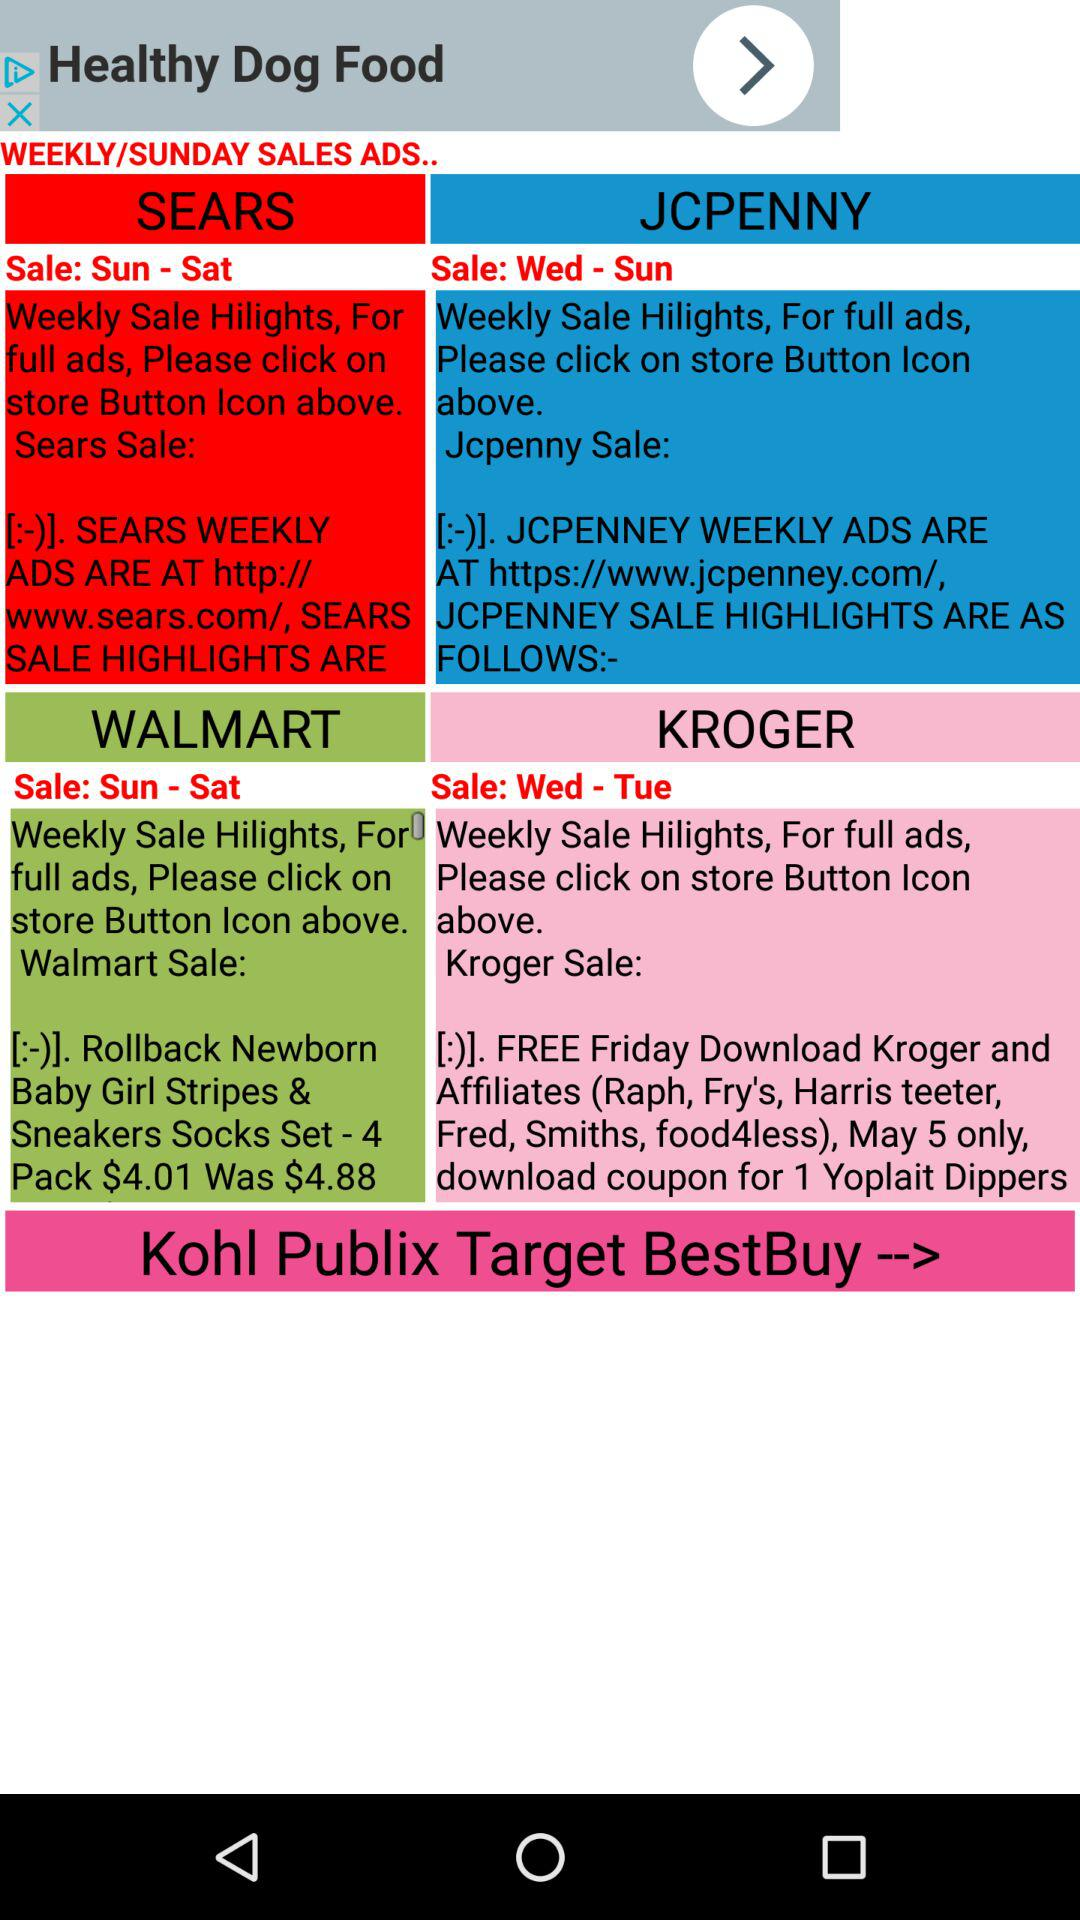What days of the week does "JCPENNY" have sales? "JCPENNY" has sales from Wednesday to Sunday. 